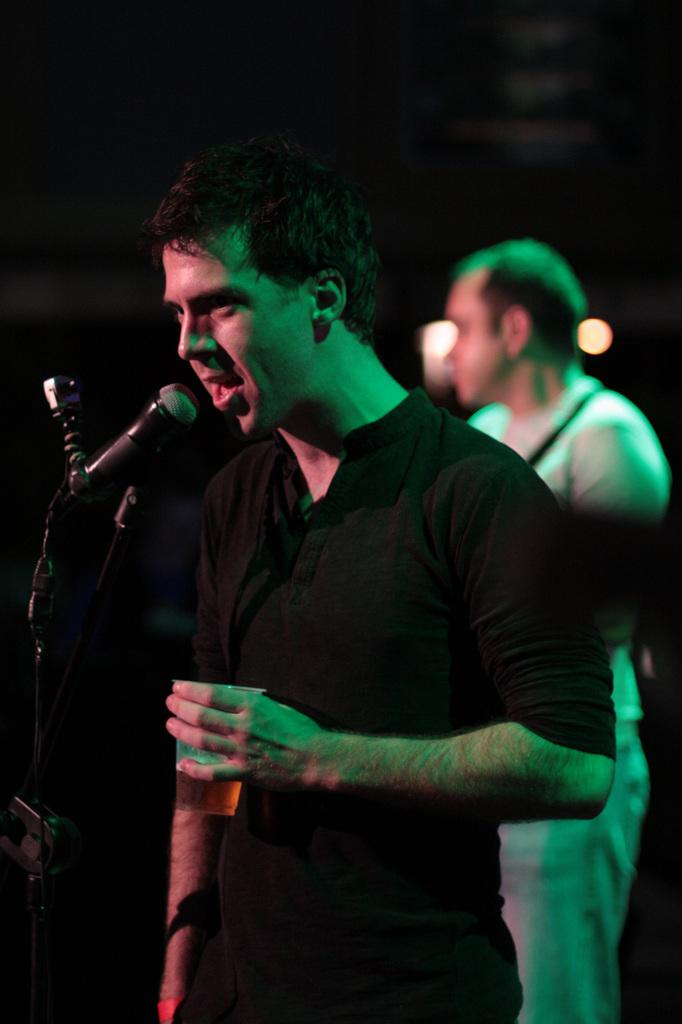What is the person in the foreground holding in the image? The person is standing and holding a glass. What object is present for amplifying sound in the image? There is a microphone with a microphone stand in the image. Can you describe the other person in the image? There is another person standing in the background. What type of vessel is the person using to order food in the image? There is no vessel or food ordering in the image; the person is holding a glass. Can you see any guns in the image? No, there are no guns present in the image. 